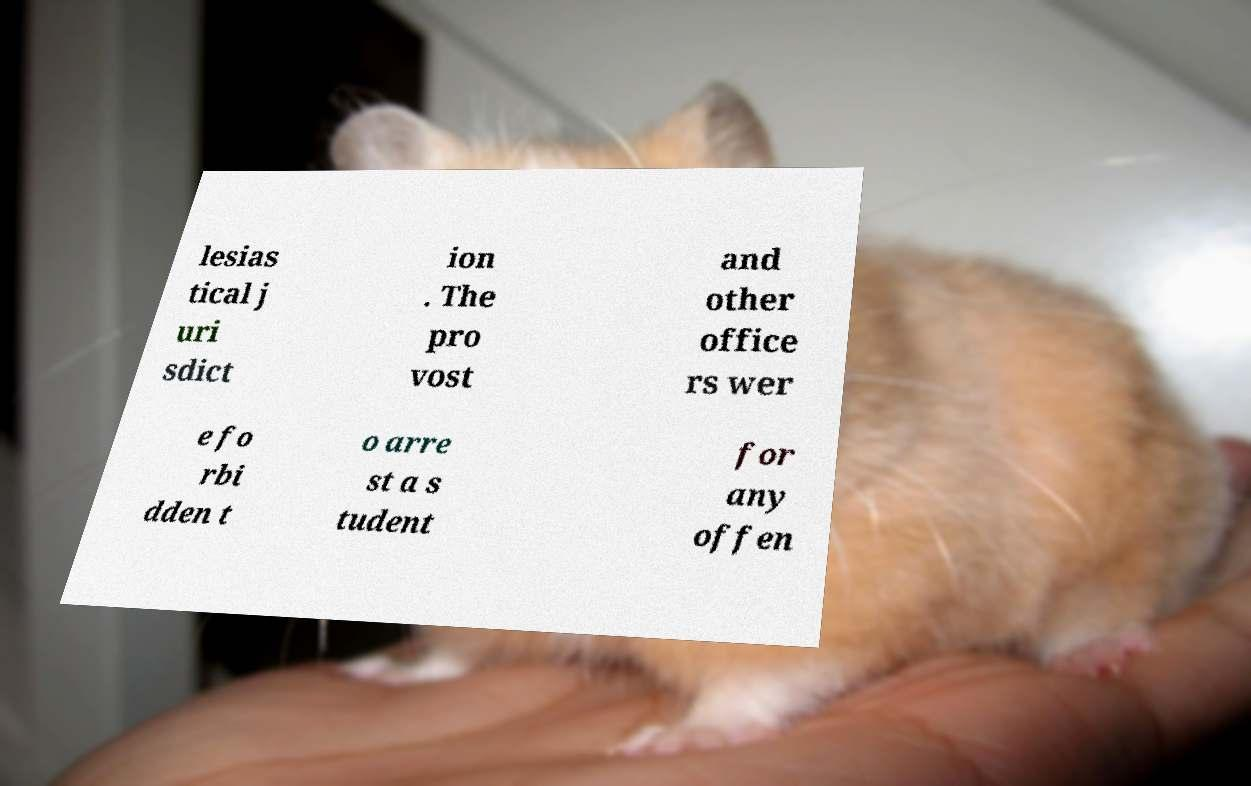There's text embedded in this image that I need extracted. Can you transcribe it verbatim? lesias tical j uri sdict ion . The pro vost and other office rs wer e fo rbi dden t o arre st a s tudent for any offen 